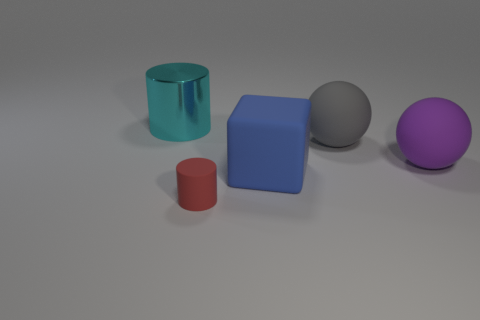Subtract all cyan cylinders. How many cylinders are left? 1 Add 3 purple metal cylinders. How many objects exist? 8 Subtract all cylinders. How many objects are left? 3 Subtract 2 balls. How many balls are left? 0 Subtract all brown cubes. Subtract all red cylinders. How many cubes are left? 1 Subtract all purple blocks. How many red cylinders are left? 1 Subtract all big matte blocks. Subtract all gray matte balls. How many objects are left? 3 Add 5 matte cylinders. How many matte cylinders are left? 6 Add 4 big blue matte cubes. How many big blue matte cubes exist? 5 Subtract 0 red spheres. How many objects are left? 5 